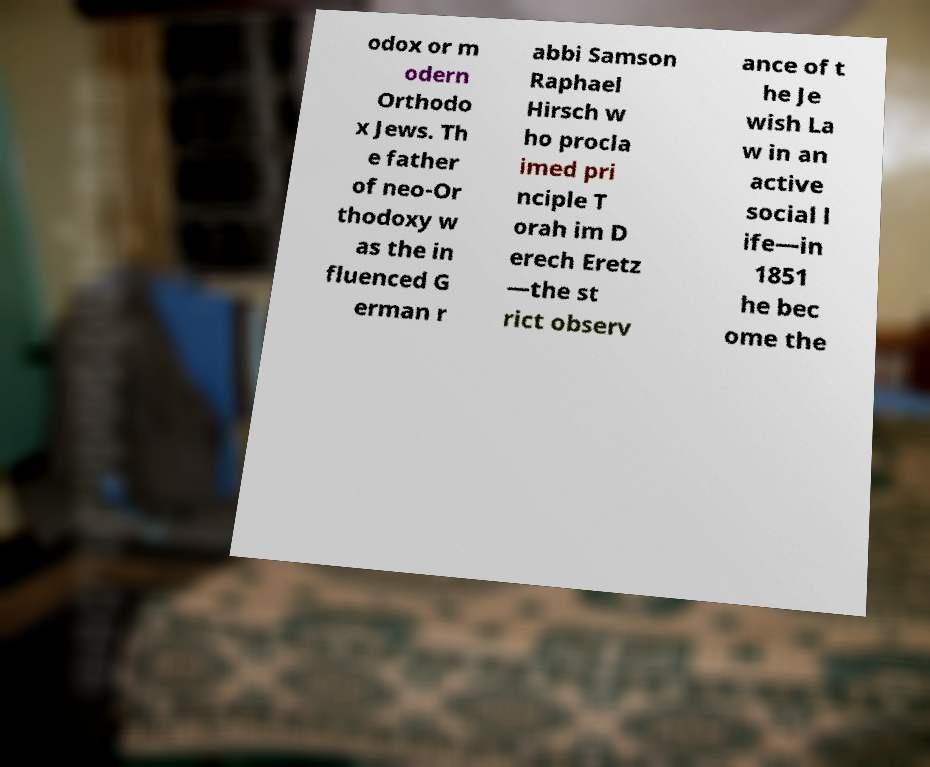Please read and relay the text visible in this image. What does it say? odox or m odern Orthodo x Jews. Th e father of neo-Or thodoxy w as the in fluenced G erman r abbi Samson Raphael Hirsch w ho procla imed pri nciple T orah im D erech Eretz —the st rict observ ance of t he Je wish La w in an active social l ife—in 1851 he bec ome the 